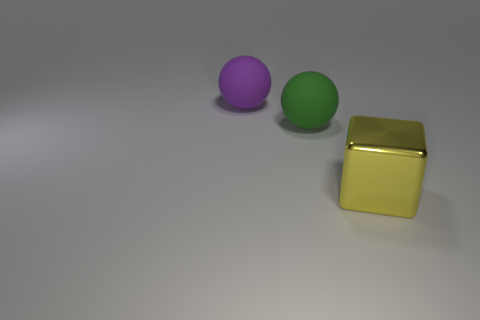What is the shape of the yellow thing?
Your answer should be compact. Cube. How many things are balls left of the green sphere or metallic cubes?
Your response must be concise. 2. Is the number of large rubber spheres that are to the left of the green thing greater than the number of tiny red matte balls?
Your response must be concise. Yes. There is a big green thing; is its shape the same as the large thing that is to the left of the large green sphere?
Keep it short and to the point. Yes. What number of small things are green rubber spheres or purple rubber spheres?
Offer a very short reply. 0. What color is the sphere that is in front of the ball that is behind the green matte ball?
Give a very brief answer. Green. Do the large green sphere and the big cube that is in front of the purple object have the same material?
Provide a succinct answer. No. What material is the thing that is in front of the big green rubber thing?
Give a very brief answer. Metal. Is the number of big purple balls on the right side of the yellow cube the same as the number of tiny brown rubber things?
Your answer should be compact. Yes. What material is the big sphere on the left side of the large matte ball that is to the right of the big purple thing?
Provide a short and direct response. Rubber. 